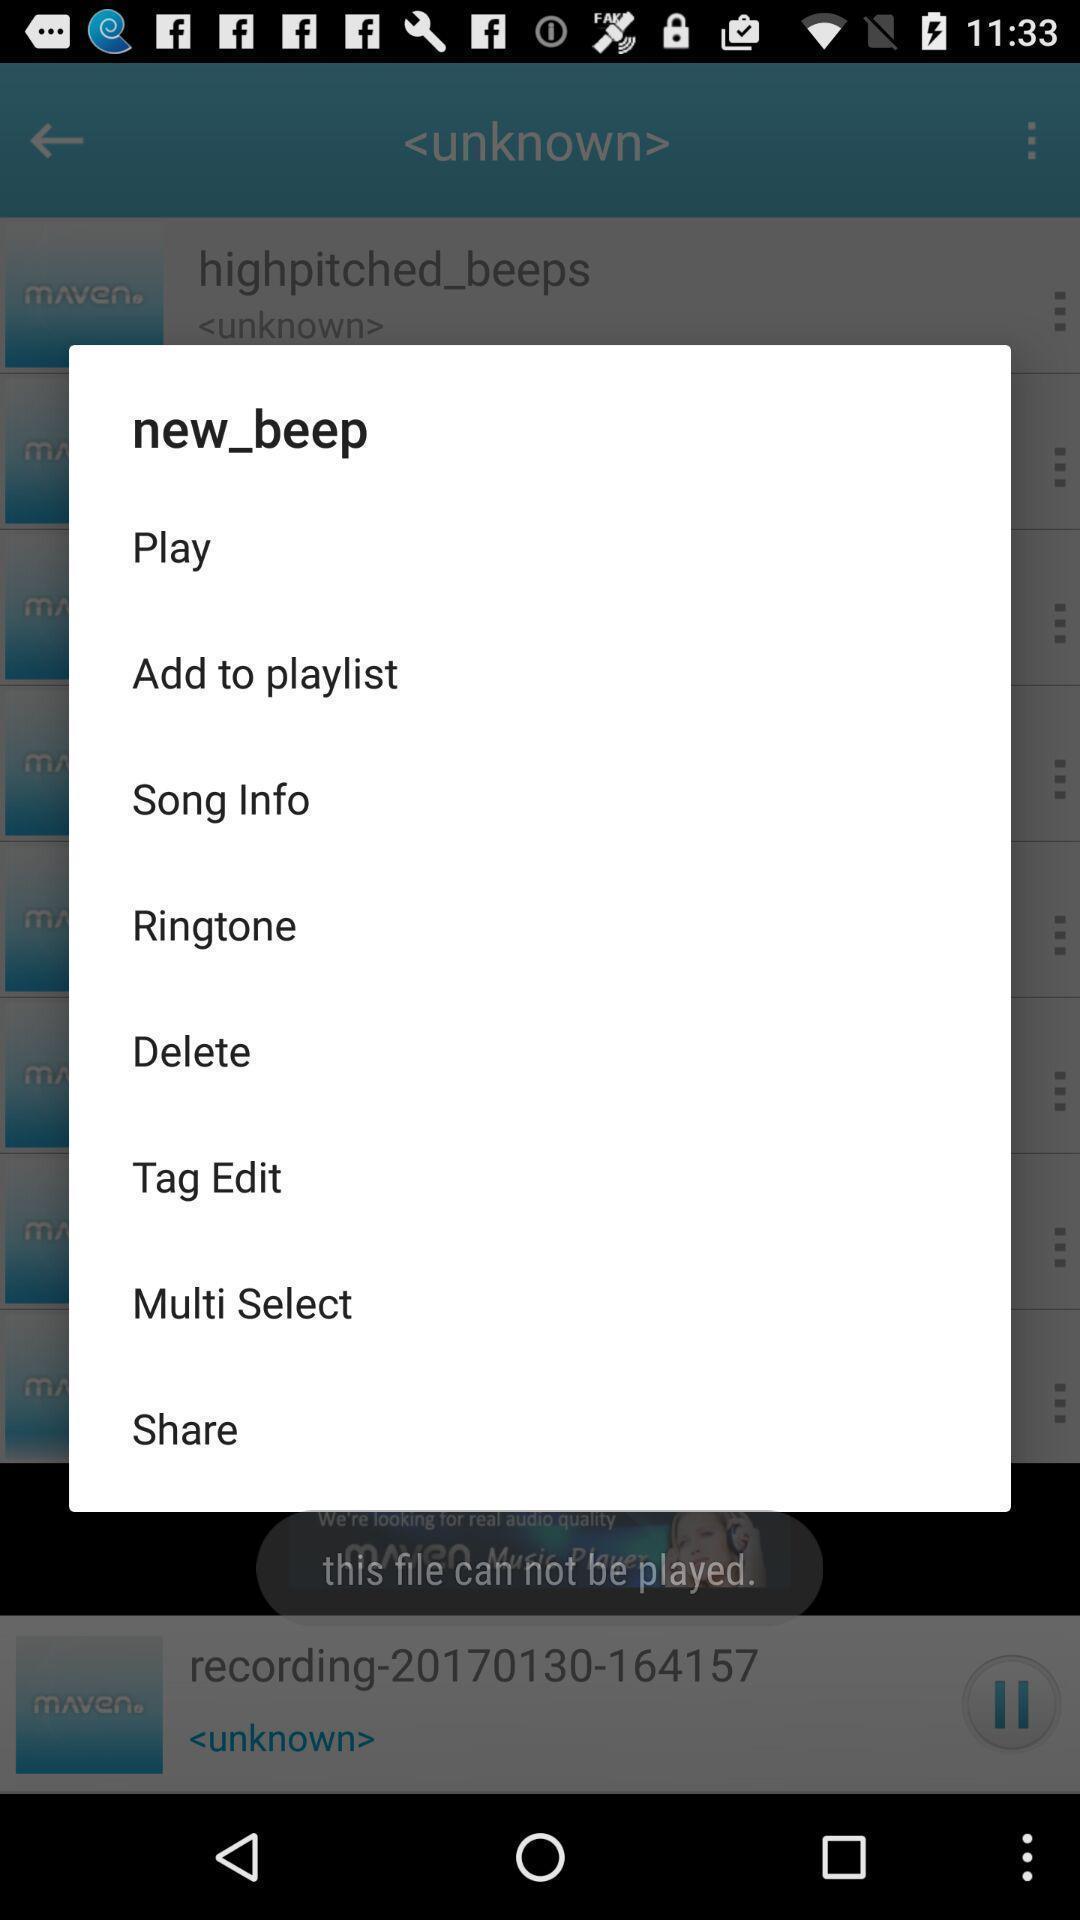Tell me about the visual elements in this screen capture. Pop up window with different options of a music app. 